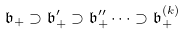<formula> <loc_0><loc_0><loc_500><loc_500>\mathfrak { b } _ { + } \supset \mathfrak { b } _ { + } ^ { \prime } \supset \mathfrak { b } _ { + } ^ { \prime \prime } \cdots \supset \mathfrak { b } _ { + } ^ { ( k ) }</formula> 